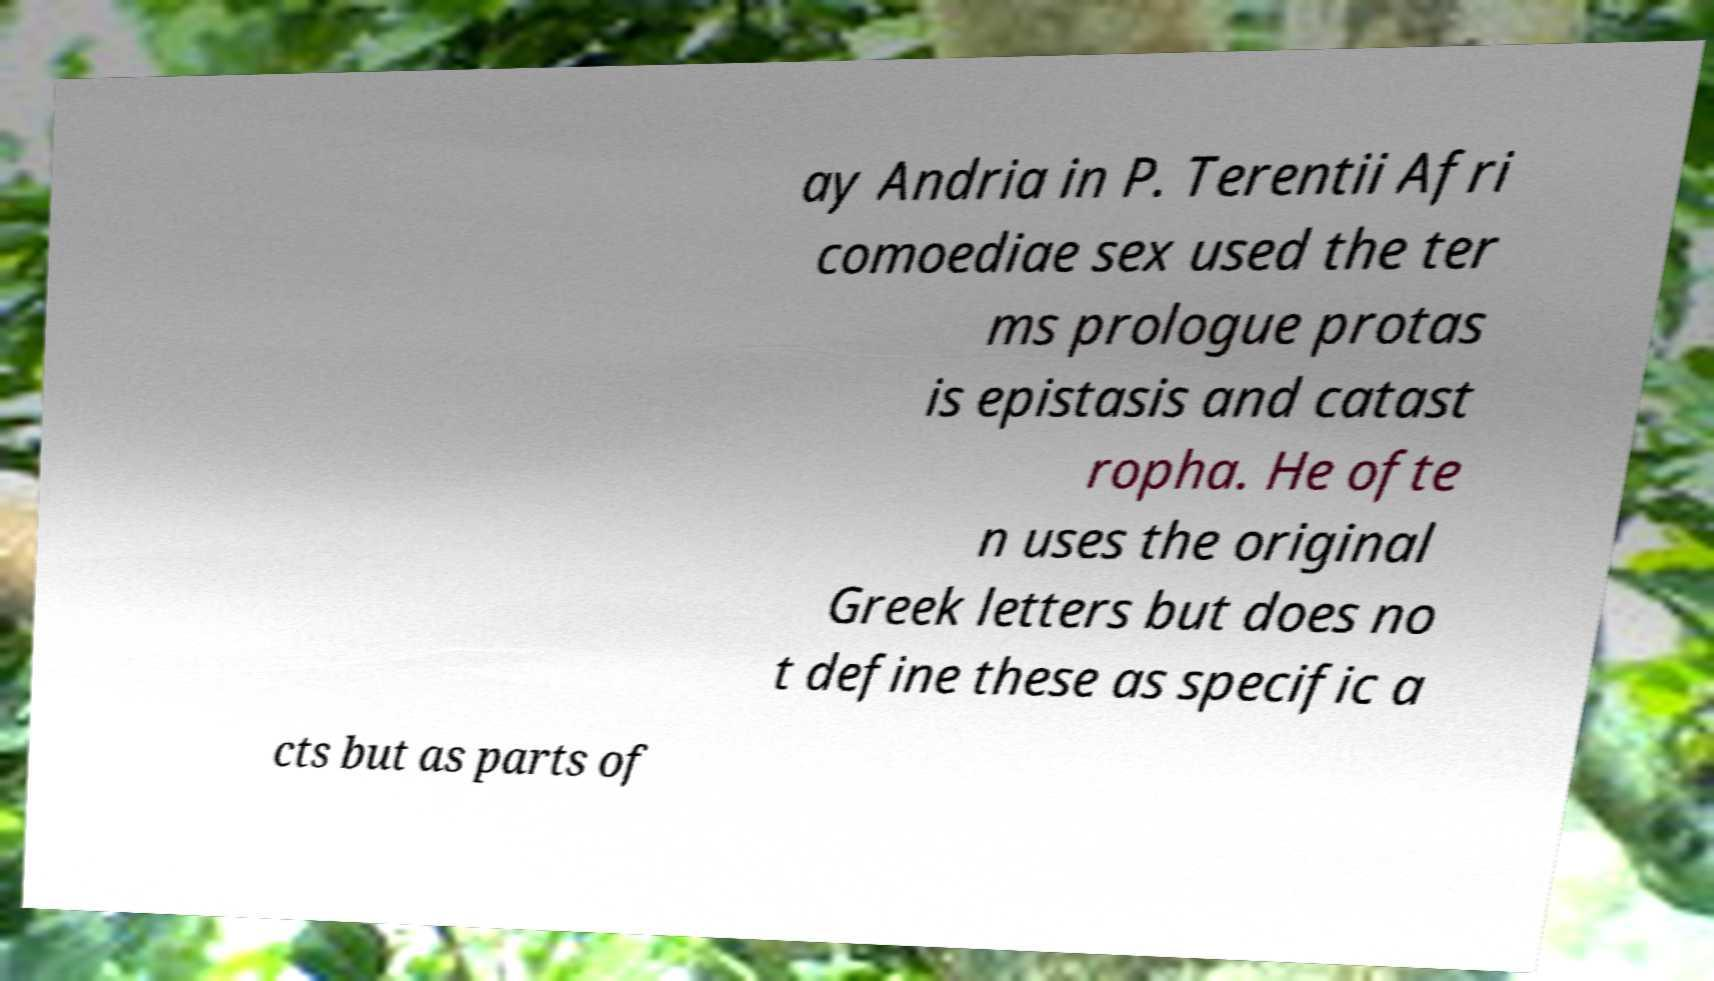Can you accurately transcribe the text from the provided image for me? ay Andria in P. Terentii Afri comoediae sex used the ter ms prologue protas is epistasis and catast ropha. He ofte n uses the original Greek letters but does no t define these as specific a cts but as parts of 